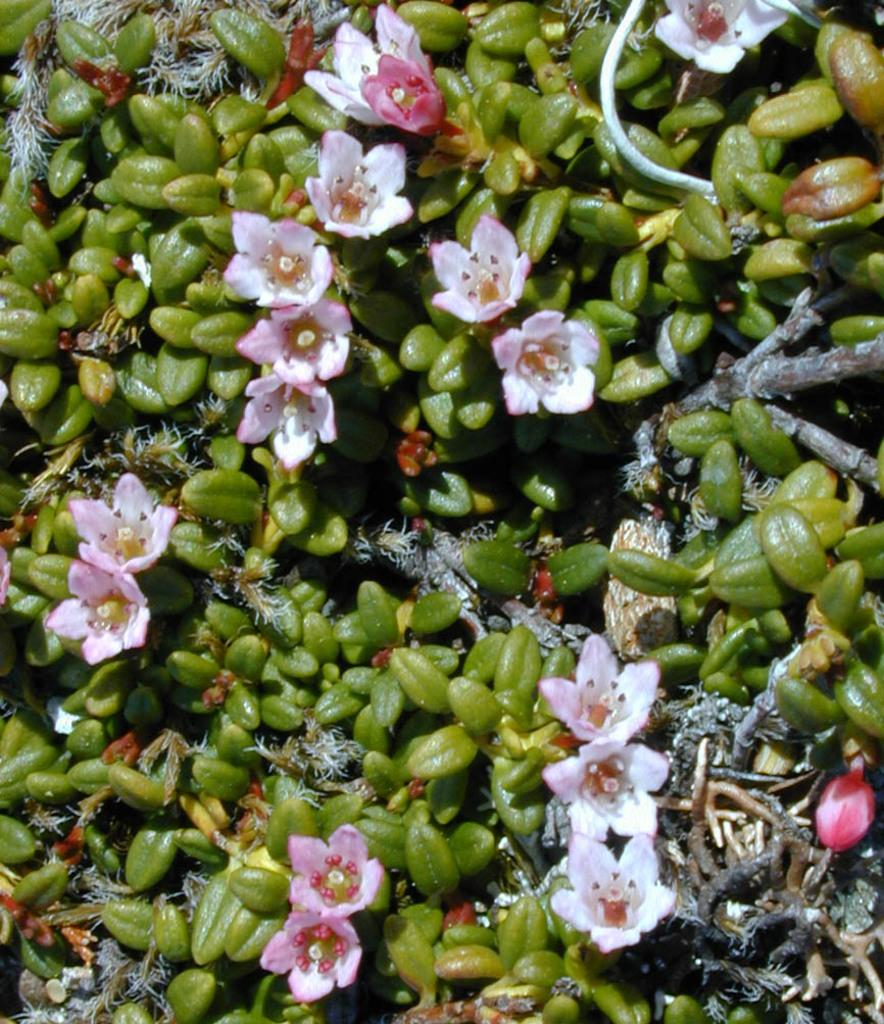What color are the flowers in the image? The flowers in the image are pink in color. What type of vegetation is present on the ground in the image? There are plants on the ground in the image. What is the color of the plants in the image? The plants in the image are green in color. What action is the moon taking in the image? There is no moon present in the image, so no action can be observed. What type of journey is depicted in the image? There is no journey depicted in the image; it features flowers and plants. 